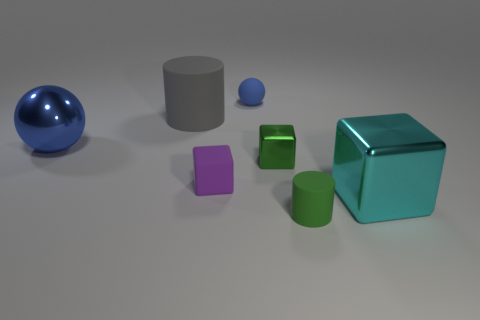What material is the large object that is behind the ball that is on the left side of the blue ball to the right of the shiny ball?
Make the answer very short. Rubber. Are there an equal number of small green cubes to the left of the purple cube and big shiny things?
Your response must be concise. No. Do the tiny block left of the small shiny object and the small green thing behind the big block have the same material?
Offer a terse response. No. What number of things are either rubber things or metal objects that are to the left of the small green shiny thing?
Your response must be concise. 5. Are there any purple objects that have the same shape as the cyan thing?
Provide a succinct answer. Yes. There is a blue ball that is in front of the blue object that is right of the blue object in front of the gray rubber object; what size is it?
Your answer should be compact. Large. Are there the same number of large cyan metallic blocks that are left of the small metallic block and large cubes behind the tiny matte cube?
Provide a short and direct response. Yes. The green object that is made of the same material as the large cylinder is what size?
Keep it short and to the point. Small. What is the color of the rubber ball?
Your answer should be compact. Blue. What number of other metallic spheres have the same color as the metallic ball?
Offer a terse response. 0. 